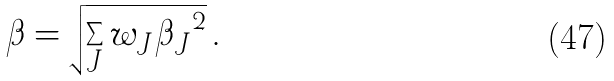<formula> <loc_0><loc_0><loc_500><loc_500>\beta = \sqrt { \sum _ { J } w _ { J } { \beta _ { J } } ^ { 2 } } \, .</formula> 